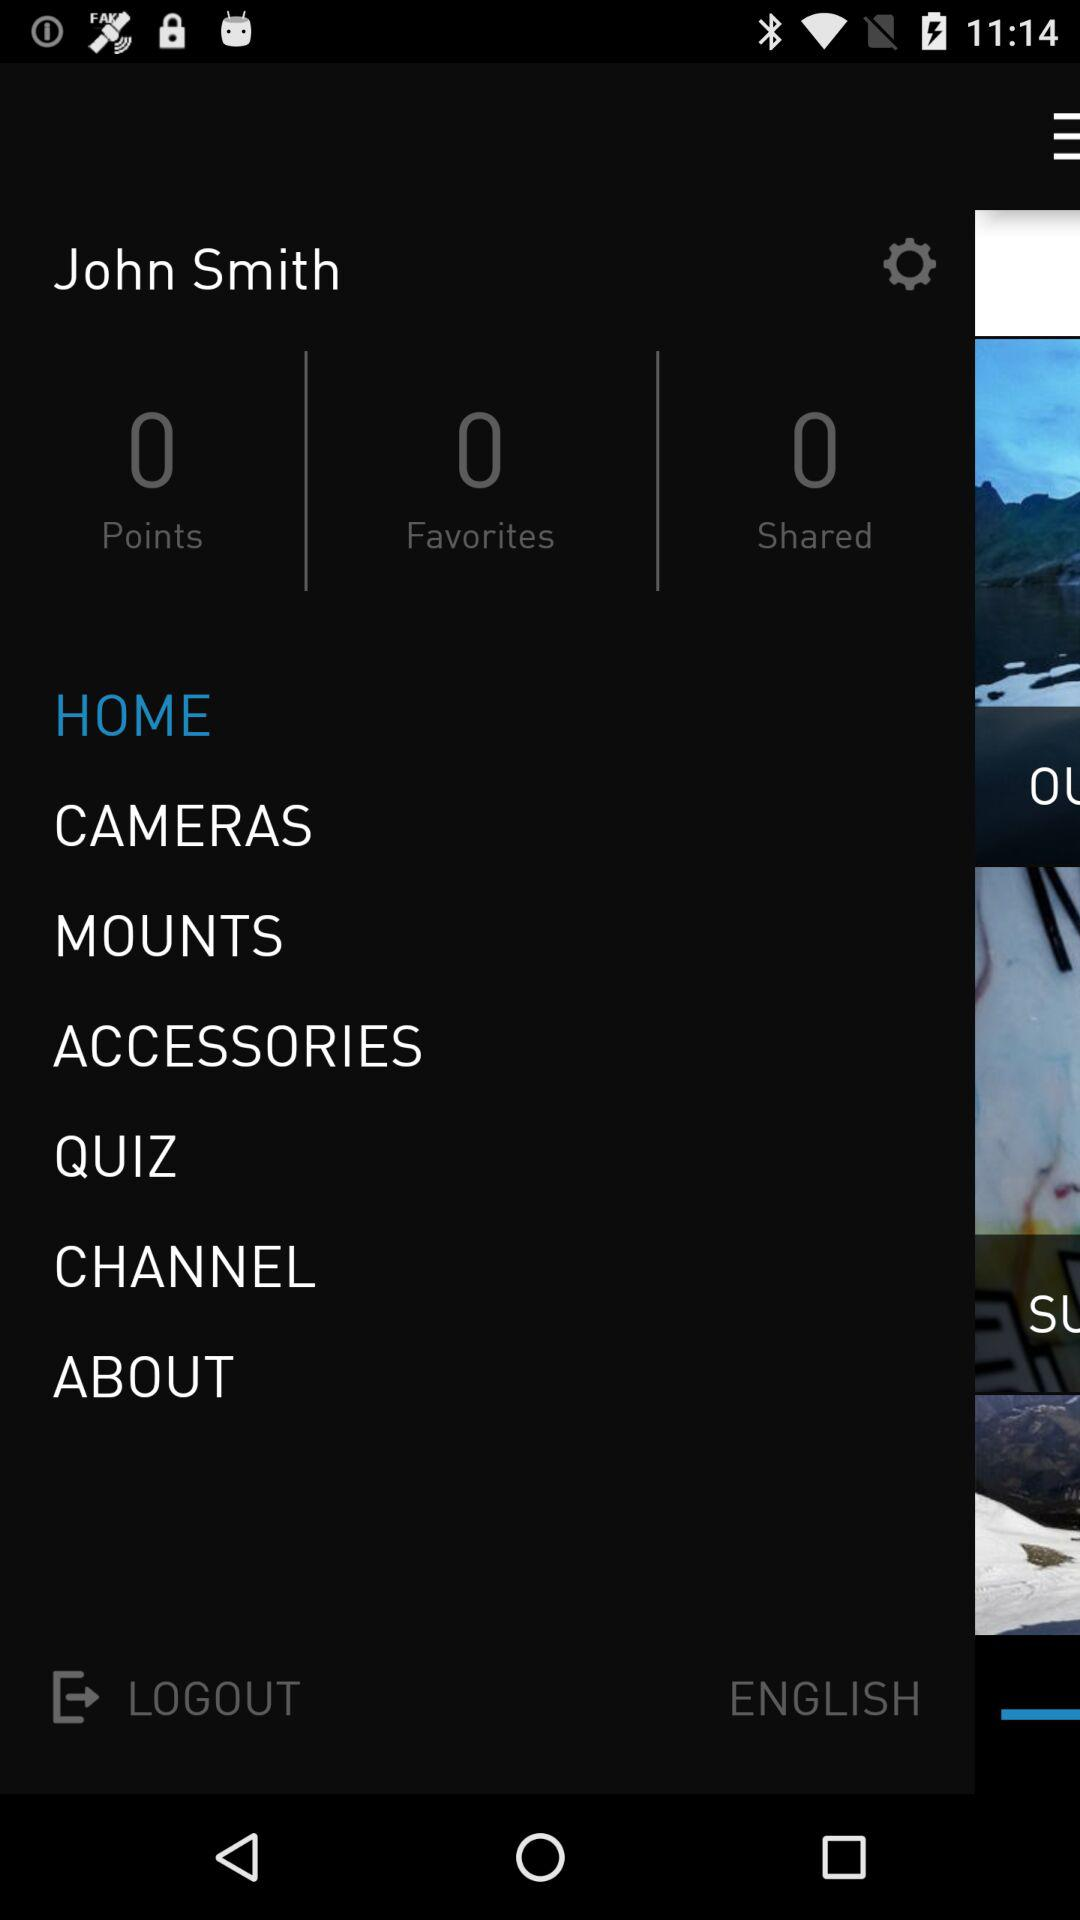What option is selected? The selected option is home. 